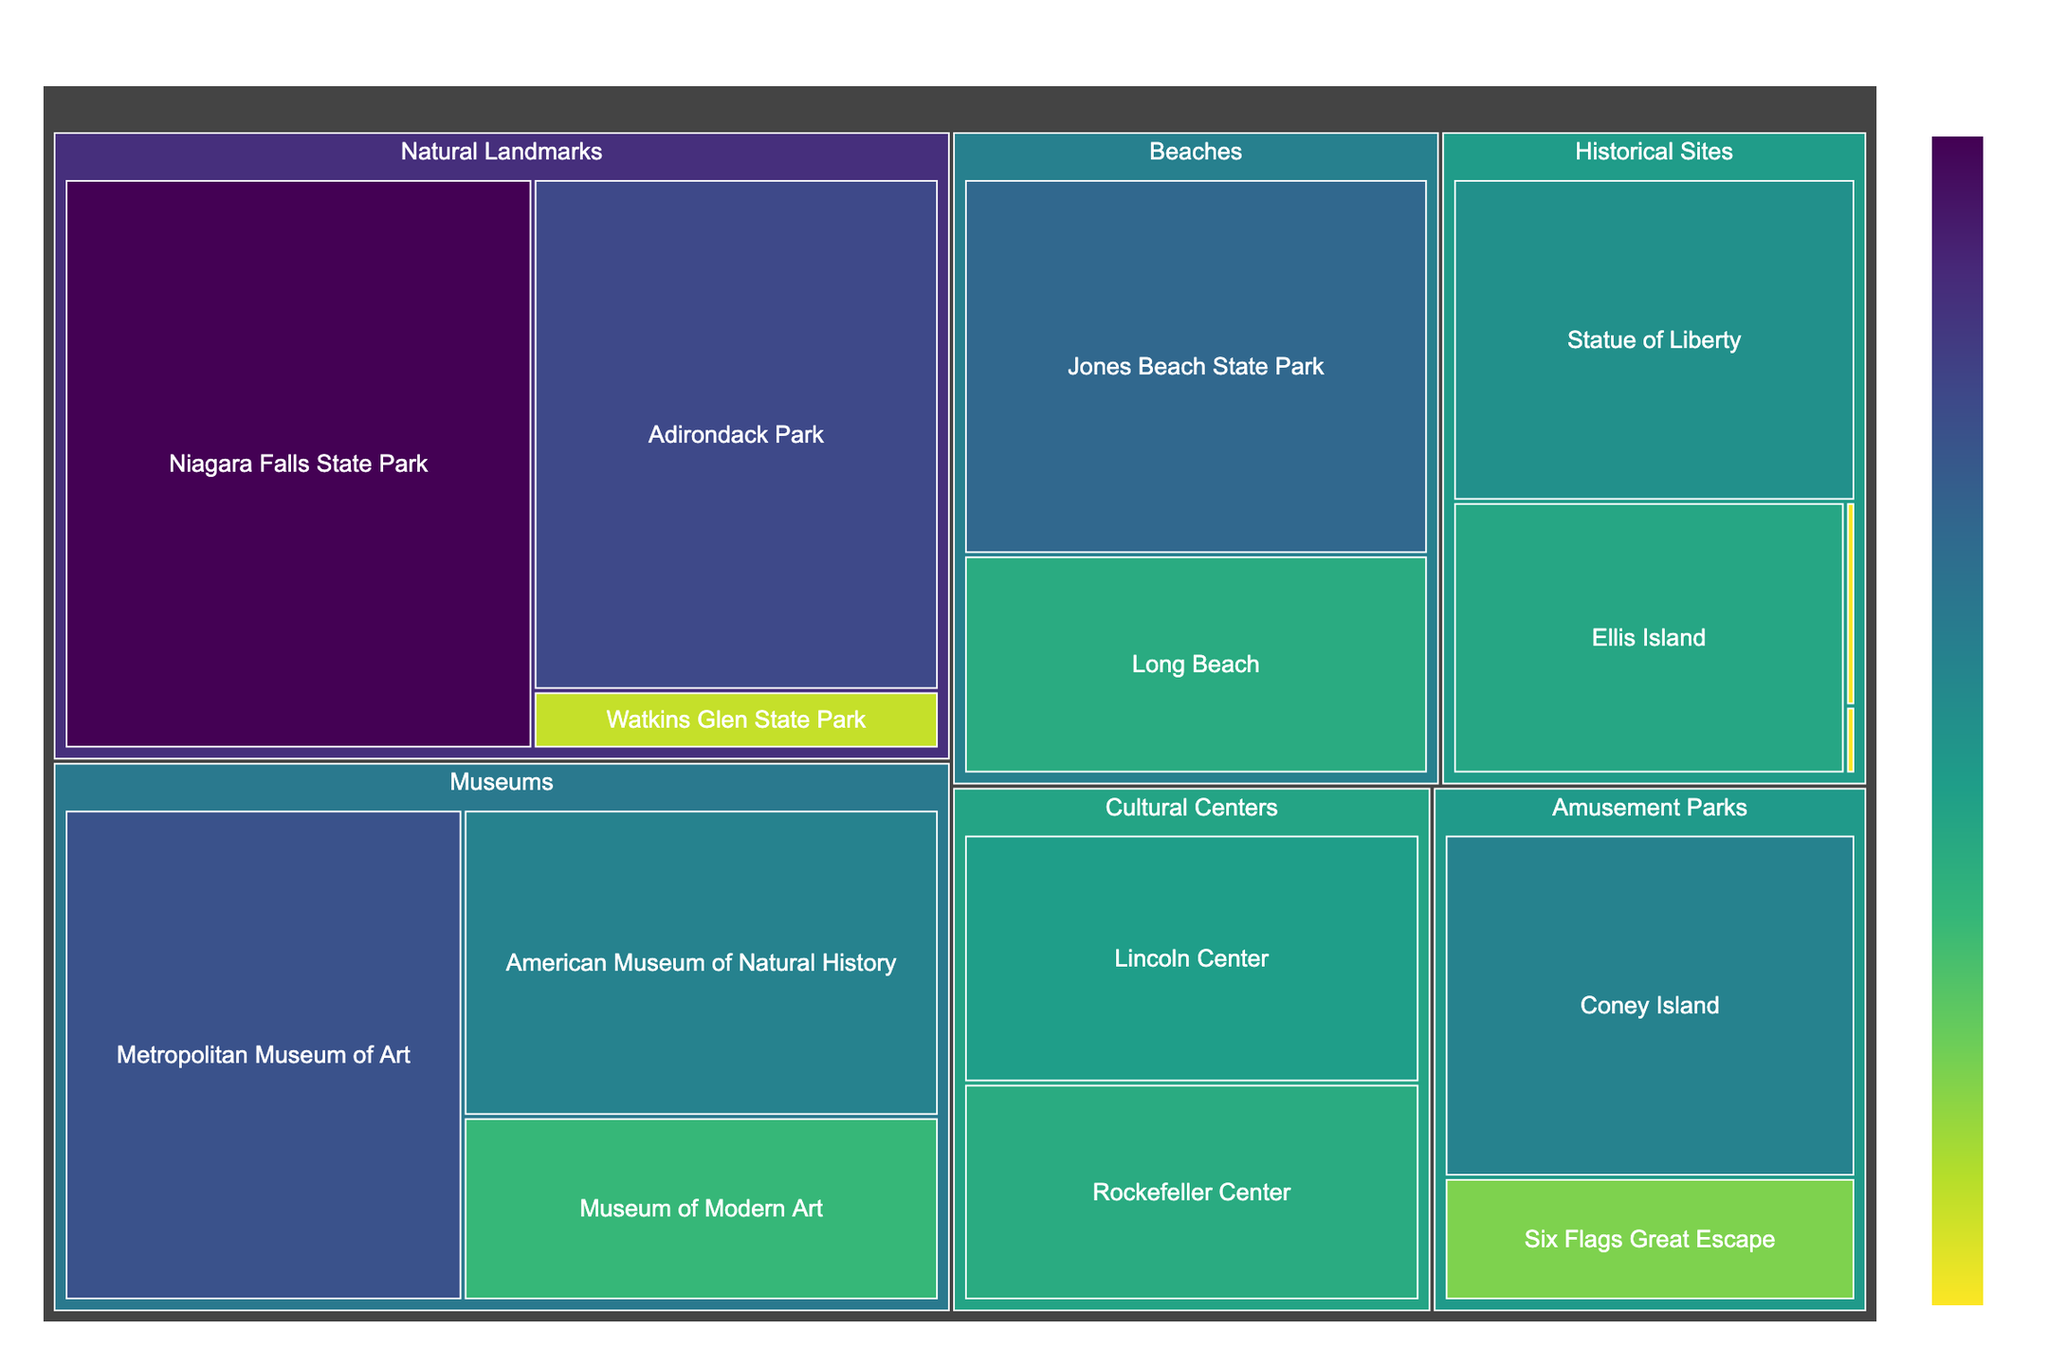Which tourist attraction has the highest number of visitors? The treemap shows visitor numbers using size and color. The largest area and darkest color represent the attraction with the highest visitors, which is Niagara Falls State Park.
Answer: Niagara Falls State Park How many visitors does the Metropolitan Museum of Art receive? Locate the Metropolitan Museum of Art under the Museums category. It shows 6,700,000 visitors.
Answer: 6,700,000 What is the total number of visitors to historical sites? Add the visitor numbers for all historical sites: Statue of Liberty (4,500,000), Ellis Island (3,700,000), Fort Ticonderoga (75,000), and Harriet Tubman Home (25,000). The total is 4,500,000 + 3,700,000 + 75,000 + 25,000 = 8,300,000.
Answer: 8,300,000 Which category has more visitors, natural landmarks or museums? Compare the sum of visitors in both categories: Natural landmarks (9,000,000 + 7,000,000 + 800,000 = 16,800,000) vs. Museums (6,700,000 + 5,000,000 + 3,000,000 = 14,700,000). Natural landmarks have more visitors.
Answer: Natural landmarks Which category has the least visited attraction? Look for the smallest and lightest-colored areas in the treemap. Harriet Tubman Home under Historical Sites is the least visited with 25,000 visitors.
Answer: Historical Sites (Harriet Tubman Home) How do visitor numbers to natural landmarks compare to beaches? Sum the visitor numbers for natural landmarks (9,000,000 + 7,000,000 + 800,000 = 16,800,000) and compare to beaches (6,000,000 + 3,500,000 = 9,500,000). Natural landmarks have more visitors.
Answer: Natural landmarks have more visitors What is the average number of visitors among amusement parks? Sum the visitors to amusement parks (1,800,000 + 5,000,000) and divide by the number of parks. (1,800,000 + 5,000,000) / 2 = 3,400,000.
Answer: 3,400,000 How many more visitors does Jones Beach State Park have compared to Long Beach? Subtract Long Beach visitors from Jones Beach State Park visitors (6,000,000 - 3,500,000 = 2,500,000).
Answer: 2,500,000 Which has more visitors, the American Museum of Natural History or the Statue of Liberty? Compare the numbers from the treemap: American Museum of Natural History (5,000,000) vs. Statue of Liberty (4,500,000). The American Museum of Natural History has more visitors.
Answer: American Museum of Natural History 